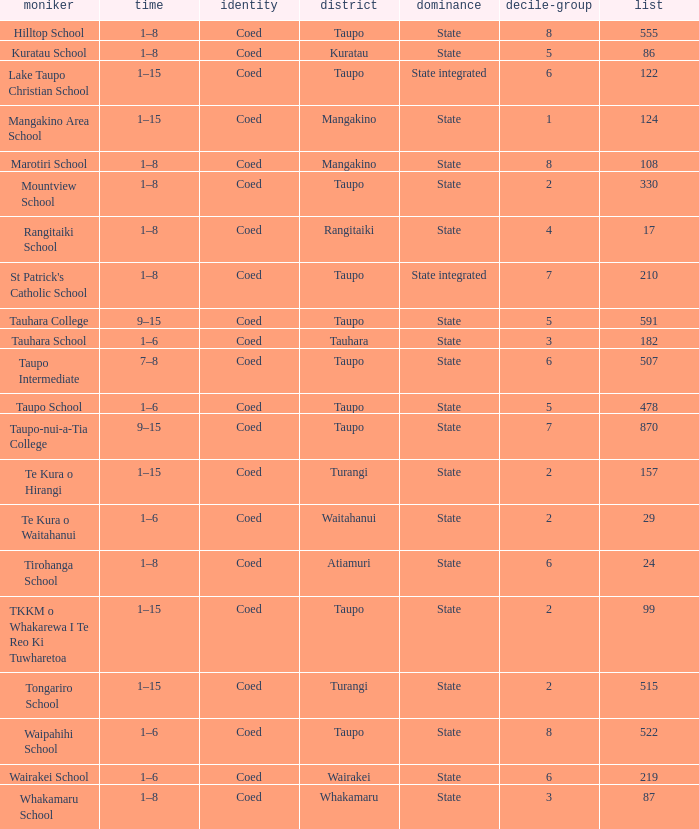What is the Whakamaru school's authority? State. 